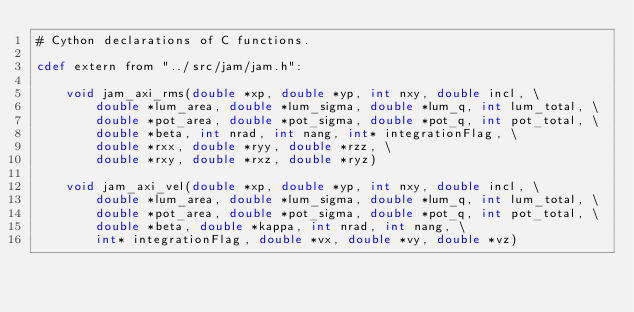Convert code to text. <code><loc_0><loc_0><loc_500><loc_500><_Cython_># Cython declarations of C functions.

cdef extern from "../src/jam/jam.h":

    void jam_axi_rms(double *xp, double *yp, int nxy, double incl, \
        double *lum_area, double *lum_sigma, double *lum_q, int lum_total, \
        double *pot_area, double *pot_sigma, double *pot_q, int pot_total, \
        double *beta, int nrad, int nang, int* integrationFlag, \
        double *rxx, double *ryy, double *rzz, \
        double *rxy, double *rxz, double *ryz)
    
    void jam_axi_vel(double *xp, double *yp, int nxy, double incl, \
        double *lum_area, double *lum_sigma, double *lum_q, int lum_total, \
        double *pot_area, double *pot_sigma, double *pot_q, int pot_total, \
        double *beta, double *kappa, int nrad, int nang, \
        int* integrationFlag, double *vx, double *vy, double *vz)
</code> 